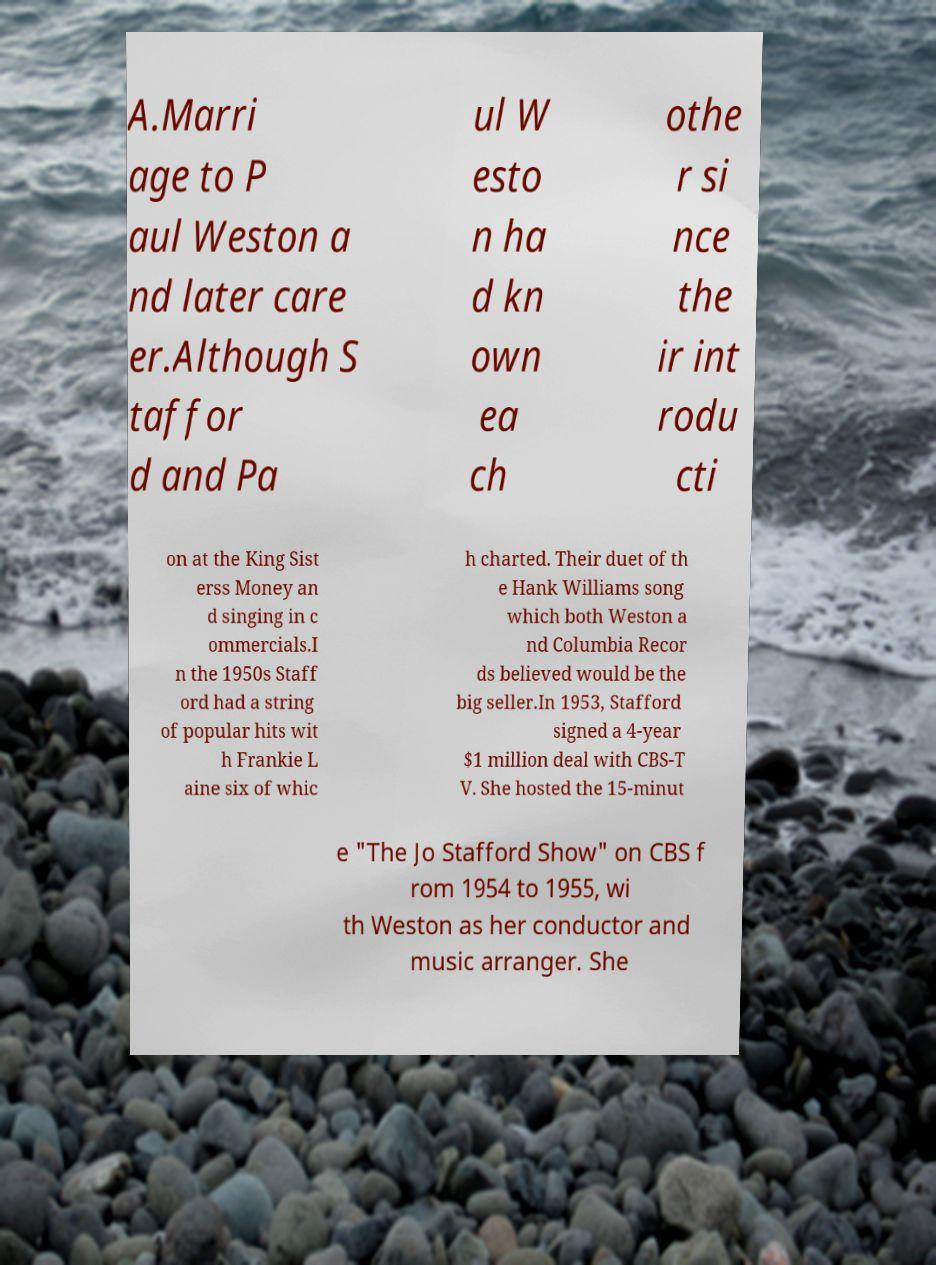What messages or text are displayed in this image? I need them in a readable, typed format. A.Marri age to P aul Weston a nd later care er.Although S taffor d and Pa ul W esto n ha d kn own ea ch othe r si nce the ir int rodu cti on at the King Sist erss Money an d singing in c ommercials.I n the 1950s Staff ord had a string of popular hits wit h Frankie L aine six of whic h charted. Their duet of th e Hank Williams song which both Weston a nd Columbia Recor ds believed would be the big seller.In 1953, Stafford signed a 4-year $1 million deal with CBS-T V. She hosted the 15-minut e "The Jo Stafford Show" on CBS f rom 1954 to 1955, wi th Weston as her conductor and music arranger. She 